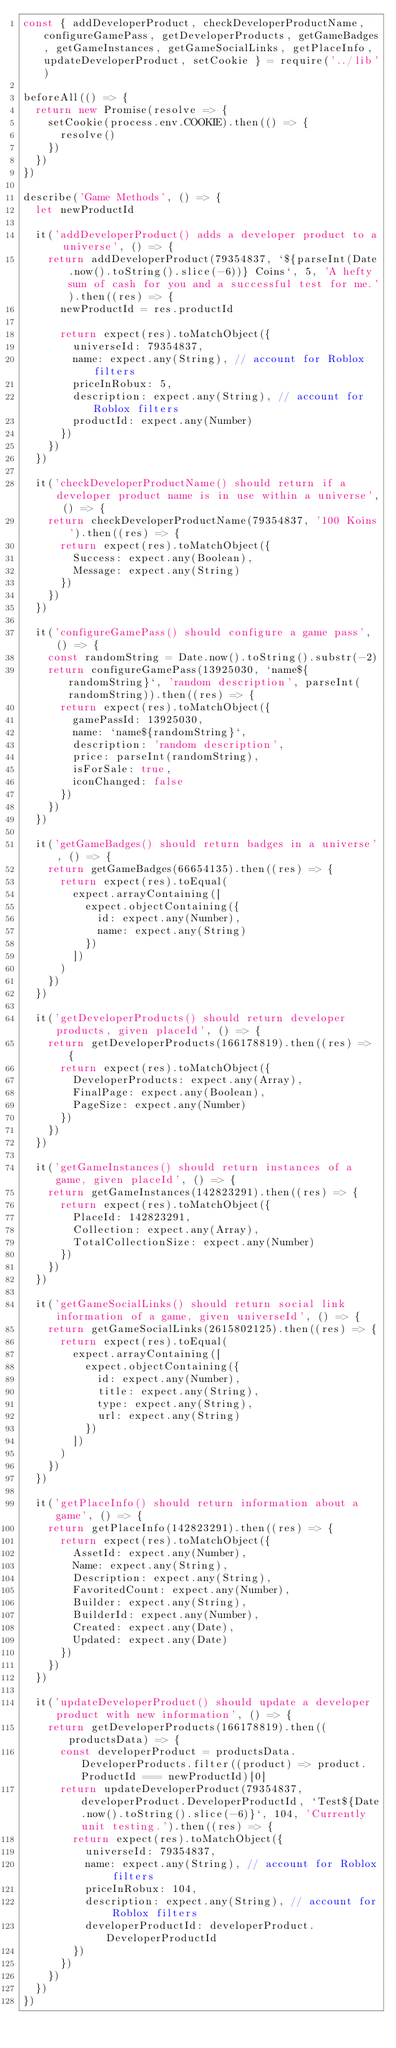Convert code to text. <code><loc_0><loc_0><loc_500><loc_500><_JavaScript_>const { addDeveloperProduct, checkDeveloperProductName, configureGamePass, getDeveloperProducts, getGameBadges, getGameInstances, getGameSocialLinks, getPlaceInfo, updateDeveloperProduct, setCookie } = require('../lib')

beforeAll(() => {
  return new Promise(resolve => {
    setCookie(process.env.COOKIE).then(() => {
      resolve()
    })
  })
})

describe('Game Methods', () => {
  let newProductId

  it('addDeveloperProduct() adds a developer product to a universe', () => {
    return addDeveloperProduct(79354837, `${parseInt(Date.now().toString().slice(-6))} Coins`, 5, 'A hefty sum of cash for you and a successful test for me.').then((res) => {
      newProductId = res.productId

      return expect(res).toMatchObject({
        universeId: 79354837,
        name: expect.any(String), // account for Roblox filters
        priceInRobux: 5,
        description: expect.any(String), // account for Roblox filters
        productId: expect.any(Number)
      })
    })
  })

  it('checkDeveloperProductName() should return if a developer product name is in use within a universe', () => {
    return checkDeveloperProductName(79354837, '100 Koins').then((res) => {
      return expect(res).toMatchObject({
        Success: expect.any(Boolean),
        Message: expect.any(String)
      })
    })
  })

  it('configureGamePass() should configure a game pass', () => {
    const randomString = Date.now().toString().substr(-2)
    return configureGamePass(13925030, `name${randomString}`, 'random description', parseInt(randomString)).then((res) => {
      return expect(res).toMatchObject({
        gamePassId: 13925030,
        name: `name${randomString}`,
        description: 'random description',
        price: parseInt(randomString),
        isForSale: true,
        iconChanged: false
      })
    })
  })

  it('getGameBadges() should return badges in a universe', () => {
    return getGameBadges(66654135).then((res) => {
      return expect(res).toEqual(
        expect.arrayContaining([
          expect.objectContaining({
            id: expect.any(Number),
            name: expect.any(String)
          })
        ])
      )
    })
  })

  it('getDeveloperProducts() should return developer products, given placeId', () => {
    return getDeveloperProducts(166178819).then((res) => {
      return expect(res).toMatchObject({
        DeveloperProducts: expect.any(Array),
        FinalPage: expect.any(Boolean),
        PageSize: expect.any(Number)
      })
    })
  })

  it('getGameInstances() should return instances of a game, given placeId', () => {
    return getGameInstances(142823291).then((res) => {
      return expect(res).toMatchObject({
        PlaceId: 142823291,
        Collection: expect.any(Array),
        TotalCollectionSize: expect.any(Number)
      })
    })
  })

  it('getGameSocialLinks() should return social link information of a game, given universeId', () => {
    return getGameSocialLinks(2615802125).then((res) => {
      return expect(res).toEqual(
        expect.arrayContaining([
          expect.objectContaining({
            id: expect.any(Number),
            title: expect.any(String),
            type: expect.any(String),
            url: expect.any(String)
          })
        ])
      )
    })
  })

  it('getPlaceInfo() should return information about a game', () => {
    return getPlaceInfo(142823291).then((res) => {
      return expect(res).toMatchObject({
        AssetId: expect.any(Number),
        Name: expect.any(String),
        Description: expect.any(String),
        FavoritedCount: expect.any(Number),
        Builder: expect.any(String),
        BuilderId: expect.any(Number),
        Created: expect.any(Date),
        Updated: expect.any(Date)
      })
    })
  })

  it('updateDeveloperProduct() should update a developer product with new information', () => {
    return getDeveloperProducts(166178819).then((productsData) => {
      const developerProduct = productsData.DeveloperProducts.filter((product) => product.ProductId === newProductId)[0]
      return updateDeveloperProduct(79354837, developerProduct.DeveloperProductId, `Test${Date.now().toString().slice(-6)}`, 104, 'Currently unit testing.').then((res) => {
        return expect(res).toMatchObject({
          universeId: 79354837,
          name: expect.any(String), // account for Roblox filters
          priceInRobux: 104,
          description: expect.any(String), // account for Roblox filters
          developerProductId: developerProduct.DeveloperProductId
        })
      })
    })
  })
})
</code> 